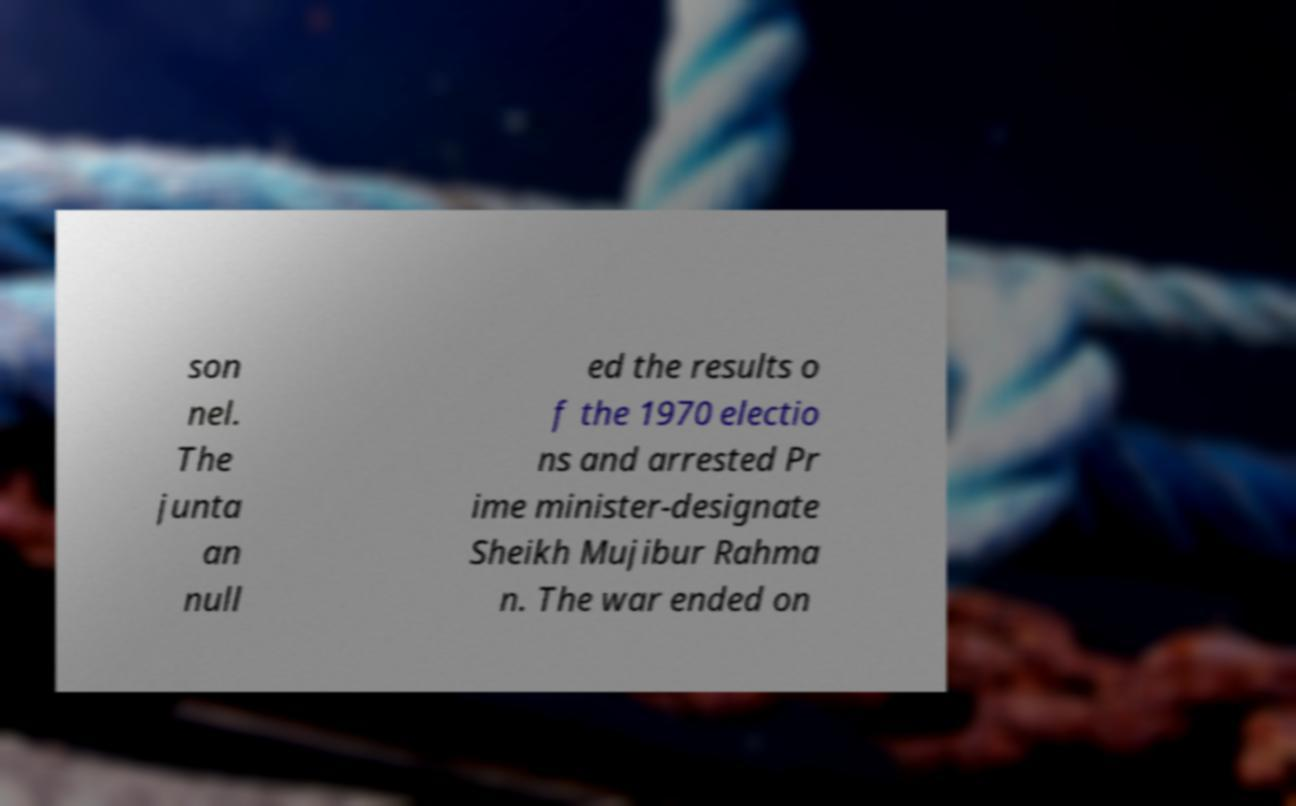Please identify and transcribe the text found in this image. son nel. The junta an null ed the results o f the 1970 electio ns and arrested Pr ime minister-designate Sheikh Mujibur Rahma n. The war ended on 